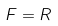<formula> <loc_0><loc_0><loc_500><loc_500>F = R</formula> 